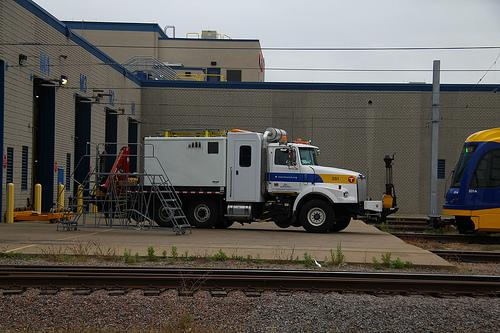What is the primary setting and action occurring in the image? The setting is an industrial area with a white work truck parked in front of a train on the tracks, surrounded by rocks and weeds. Provide a description of the main elements in the image. The image features a white truck parked near a yellow and blue train, train tracks surrounded by weeds and rocks, and a building. Describe the composition of the photograph in terms of its main subjects. The photograph captures a parked white truck, a colorful train, train tracks surrounded by weeds, and rocks next to the tracks. Mention the primary elements depicted in the image and their interaction. A white work truck is parked in front of a yellow and blue train, with weeds growing next to the train tracks and rocks alongside them. Tell a short story based on the photograph. In an industrial area, a driver parked their white truck in front of a fascinating yellow and blue train, admiring the landscape made up of rugged train tracks, rocks, and weeds. Narrate the main actions in the photograph that are related to transportation. A white truck is parked close to a vibrant yellow and blue train, which rests on train tracks, potentially suggesting a transportation hub. Write a caption to describe the scene in the photograph. A parked white truck facing a vibrant yellow and blue train with train tracks, weeds, and rocks around the area. What are the main vehicles and important objects present in this image? The main vehicles are a white truck and a yellow and blue train. Important objects include train tracks, weeds, rocks, and a building. In a few words, describe the focal points of this image. White truck, yellow and blue train, train tracks, weeds, rocks. Provide a brief overview of the scene in the image. The image shows a truck, a train, train tracks, rocks, and weeds coexisting in what appears to be an industrial setting. 